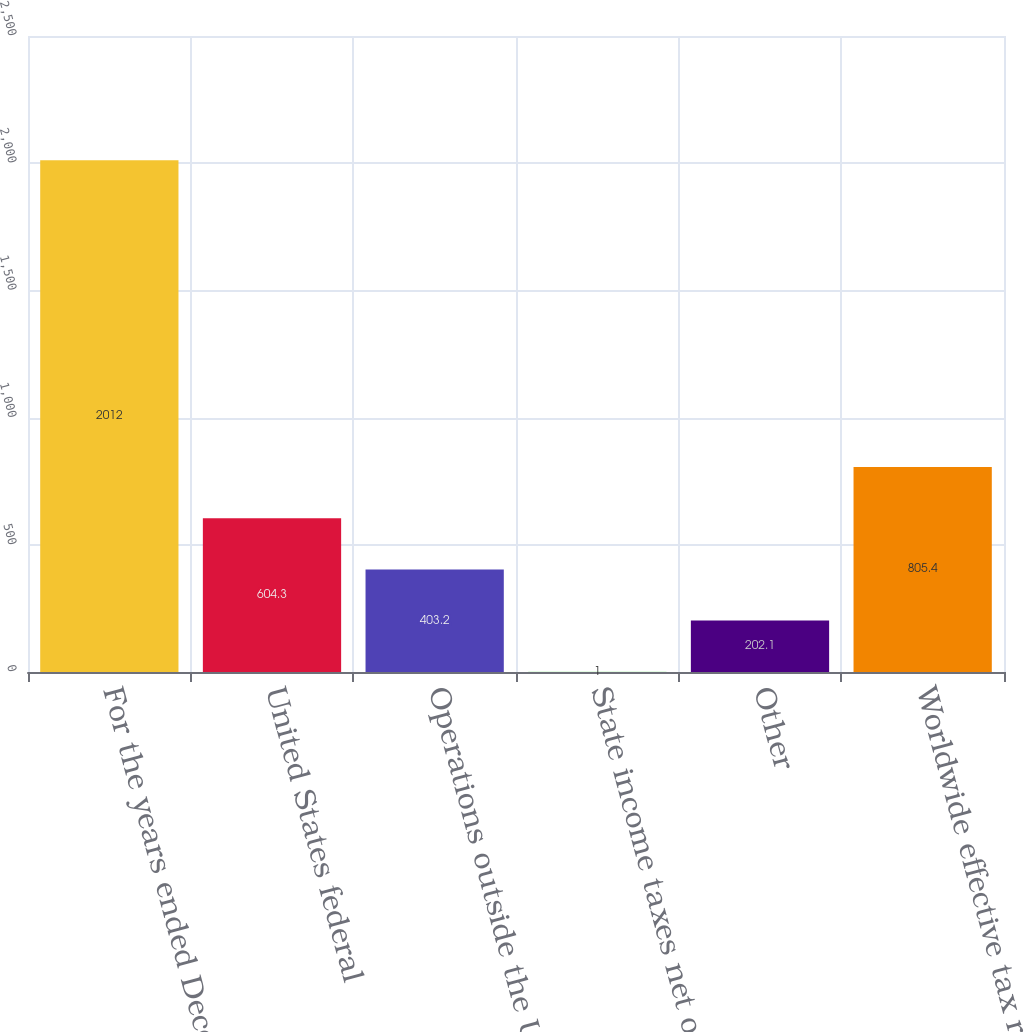Convert chart. <chart><loc_0><loc_0><loc_500><loc_500><bar_chart><fcel>For the years ended December<fcel>United States federal<fcel>Operations outside the United<fcel>State income taxes net of<fcel>Other<fcel>Worldwide effective tax rate<nl><fcel>2012<fcel>604.3<fcel>403.2<fcel>1<fcel>202.1<fcel>805.4<nl></chart> 